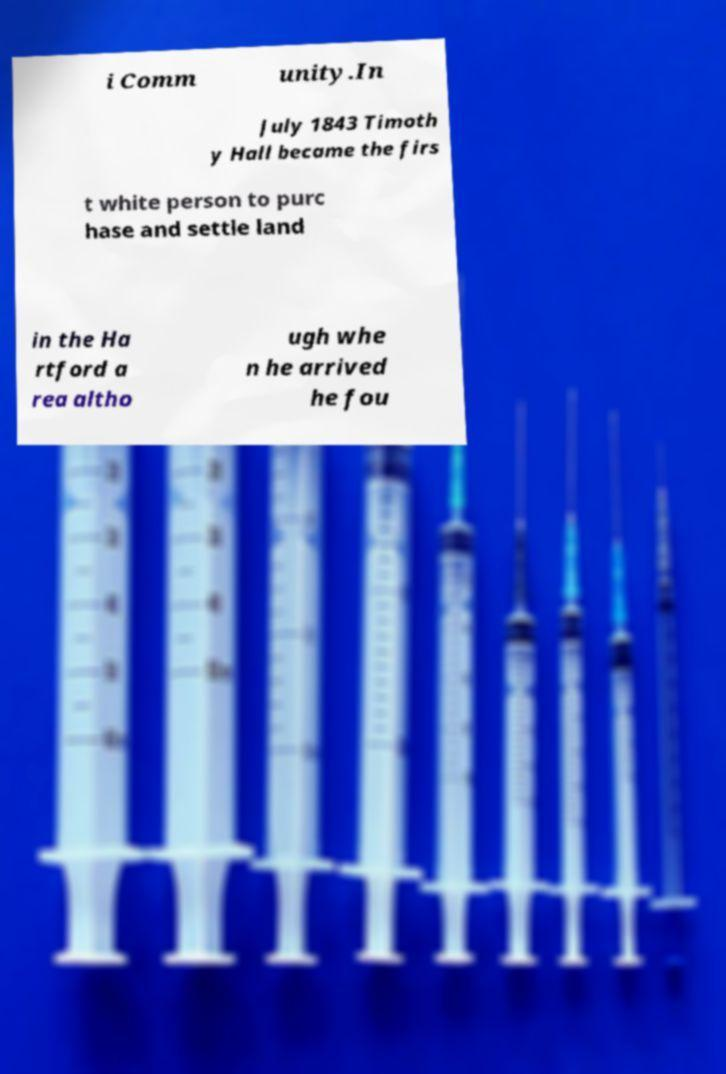I need the written content from this picture converted into text. Can you do that? i Comm unity.In July 1843 Timoth y Hall became the firs t white person to purc hase and settle land in the Ha rtford a rea altho ugh whe n he arrived he fou 